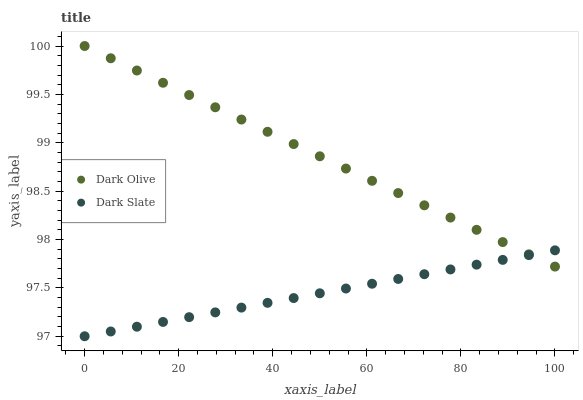Does Dark Slate have the minimum area under the curve?
Answer yes or no. Yes. Does Dark Olive have the maximum area under the curve?
Answer yes or no. Yes. Does Dark Olive have the minimum area under the curve?
Answer yes or no. No. Is Dark Slate the smoothest?
Answer yes or no. Yes. Is Dark Olive the roughest?
Answer yes or no. Yes. Is Dark Olive the smoothest?
Answer yes or no. No. Does Dark Slate have the lowest value?
Answer yes or no. Yes. Does Dark Olive have the lowest value?
Answer yes or no. No. Does Dark Olive have the highest value?
Answer yes or no. Yes. Does Dark Olive intersect Dark Slate?
Answer yes or no. Yes. Is Dark Olive less than Dark Slate?
Answer yes or no. No. Is Dark Olive greater than Dark Slate?
Answer yes or no. No. 